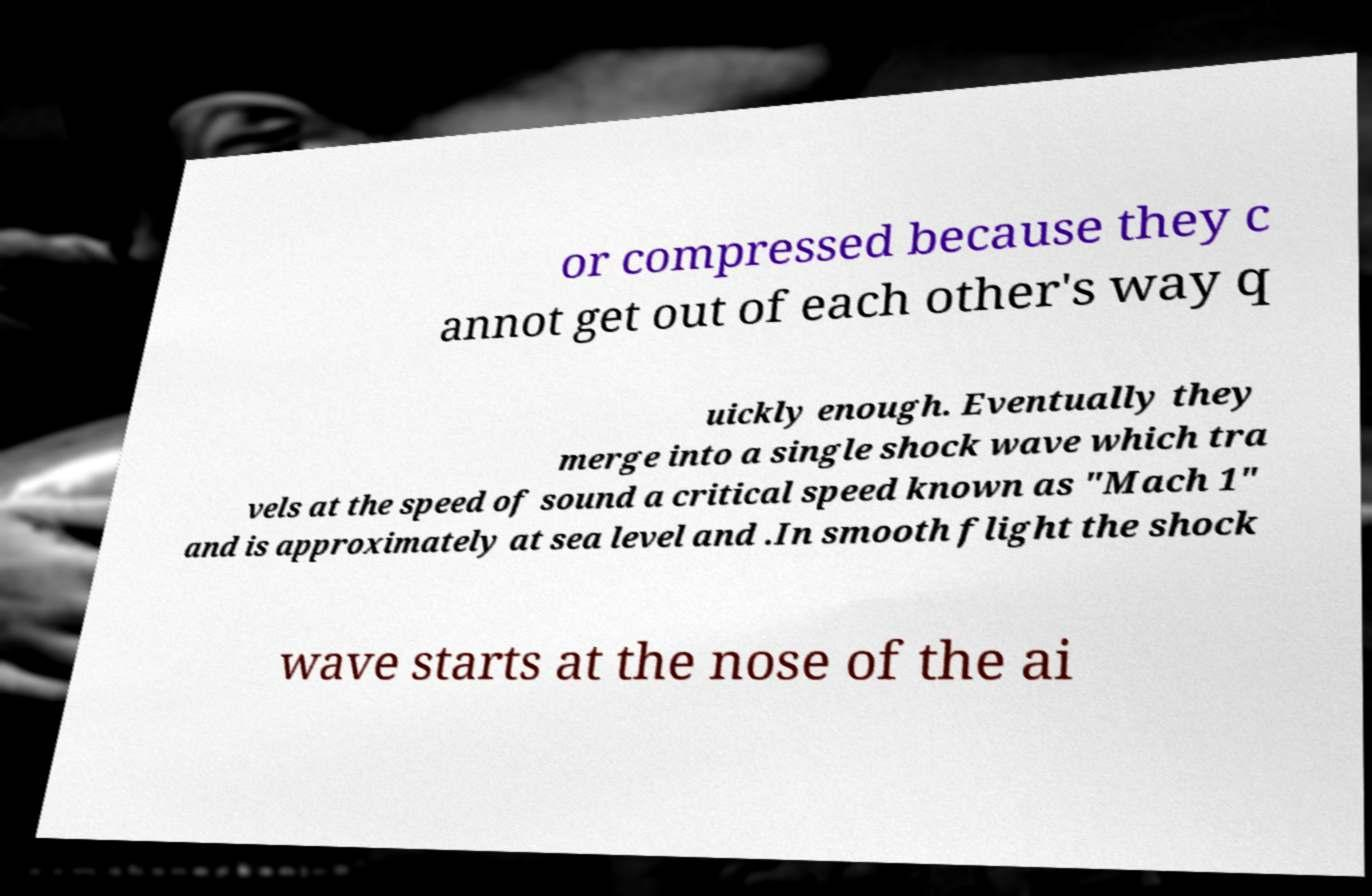Could you assist in decoding the text presented in this image and type it out clearly? or compressed because they c annot get out of each other's way q uickly enough. Eventually they merge into a single shock wave which tra vels at the speed of sound a critical speed known as "Mach 1" and is approximately at sea level and .In smooth flight the shock wave starts at the nose of the ai 